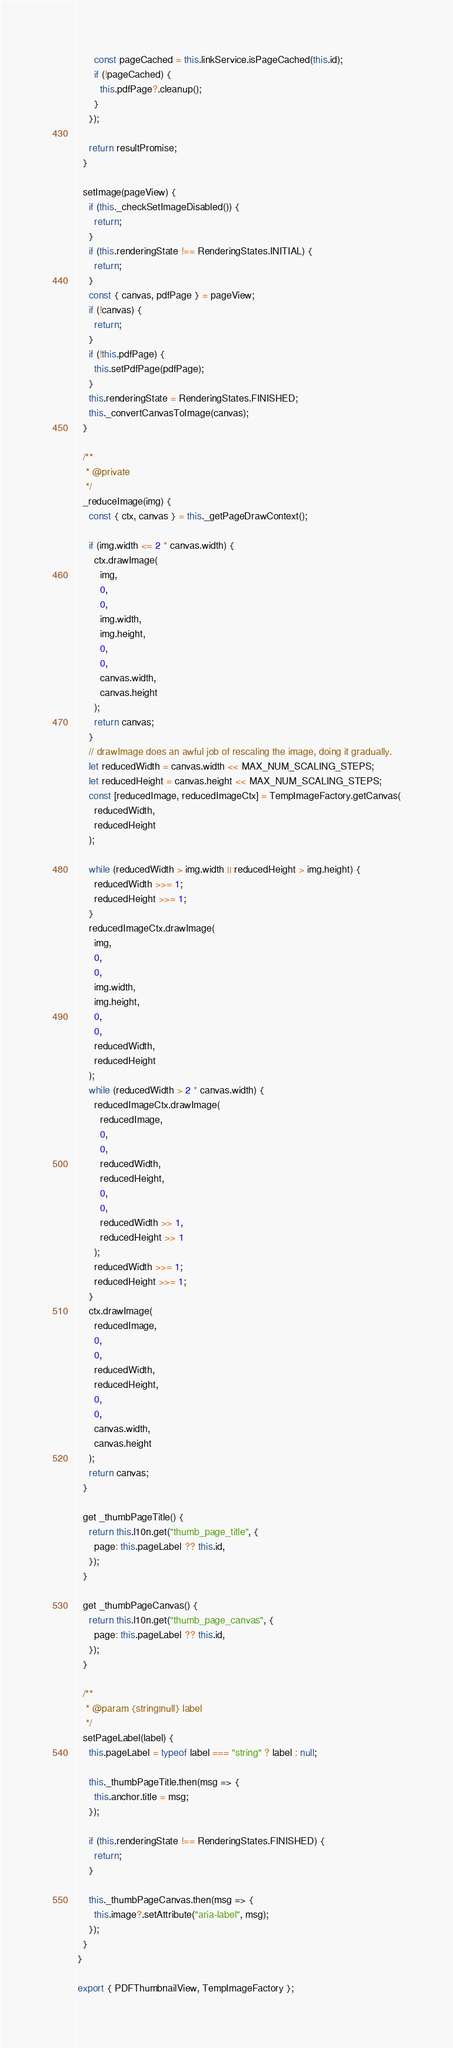Convert code to text. <code><loc_0><loc_0><loc_500><loc_500><_JavaScript_>      const pageCached = this.linkService.isPageCached(this.id);
      if (!pageCached) {
        this.pdfPage?.cleanup();
      }
    });

    return resultPromise;
  }

  setImage(pageView) {
    if (this._checkSetImageDisabled()) {
      return;
    }
    if (this.renderingState !== RenderingStates.INITIAL) {
      return;
    }
    const { canvas, pdfPage } = pageView;
    if (!canvas) {
      return;
    }
    if (!this.pdfPage) {
      this.setPdfPage(pdfPage);
    }
    this.renderingState = RenderingStates.FINISHED;
    this._convertCanvasToImage(canvas);
  }

  /**
   * @private
   */
  _reduceImage(img) {
    const { ctx, canvas } = this._getPageDrawContext();

    if (img.width <= 2 * canvas.width) {
      ctx.drawImage(
        img,
        0,
        0,
        img.width,
        img.height,
        0,
        0,
        canvas.width,
        canvas.height
      );
      return canvas;
    }
    // drawImage does an awful job of rescaling the image, doing it gradually.
    let reducedWidth = canvas.width << MAX_NUM_SCALING_STEPS;
    let reducedHeight = canvas.height << MAX_NUM_SCALING_STEPS;
    const [reducedImage, reducedImageCtx] = TempImageFactory.getCanvas(
      reducedWidth,
      reducedHeight
    );

    while (reducedWidth > img.width || reducedHeight > img.height) {
      reducedWidth >>= 1;
      reducedHeight >>= 1;
    }
    reducedImageCtx.drawImage(
      img,
      0,
      0,
      img.width,
      img.height,
      0,
      0,
      reducedWidth,
      reducedHeight
    );
    while (reducedWidth > 2 * canvas.width) {
      reducedImageCtx.drawImage(
        reducedImage,
        0,
        0,
        reducedWidth,
        reducedHeight,
        0,
        0,
        reducedWidth >> 1,
        reducedHeight >> 1
      );
      reducedWidth >>= 1;
      reducedHeight >>= 1;
    }
    ctx.drawImage(
      reducedImage,
      0,
      0,
      reducedWidth,
      reducedHeight,
      0,
      0,
      canvas.width,
      canvas.height
    );
    return canvas;
  }

  get _thumbPageTitle() {
    return this.l10n.get("thumb_page_title", {
      page: this.pageLabel ?? this.id,
    });
  }

  get _thumbPageCanvas() {
    return this.l10n.get("thumb_page_canvas", {
      page: this.pageLabel ?? this.id,
    });
  }

  /**
   * @param {string|null} label
   */
  setPageLabel(label) {
    this.pageLabel = typeof label === "string" ? label : null;

    this._thumbPageTitle.then(msg => {
      this.anchor.title = msg;
    });

    if (this.renderingState !== RenderingStates.FINISHED) {
      return;
    }

    this._thumbPageCanvas.then(msg => {
      this.image?.setAttribute("aria-label", msg);
    });
  }
}

export { PDFThumbnailView, TempImageFactory };
</code> 